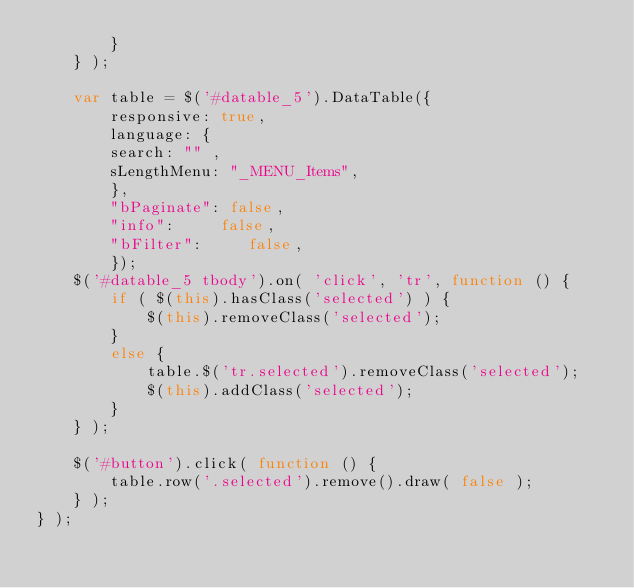<code> <loc_0><loc_0><loc_500><loc_500><_JavaScript_>		}
	} );
	
	var table = $('#datable_5').DataTable({
		responsive: true,
		language: { 
		search: "" ,
		sLengthMenu: "_MENU_Items",
		},
		"bPaginate": false,
		"info":     false,
		"bFilter":     false,
		});
	$('#datable_5 tbody').on( 'click', 'tr', function () {
        if ( $(this).hasClass('selected') ) {
            $(this).removeClass('selected');
        }
        else {
            table.$('tr.selected').removeClass('selected');
            $(this).addClass('selected');
        }
    } );
 
    $('#button').click( function () {
        table.row('.selected').remove().draw( false );
    } );
} );</code> 